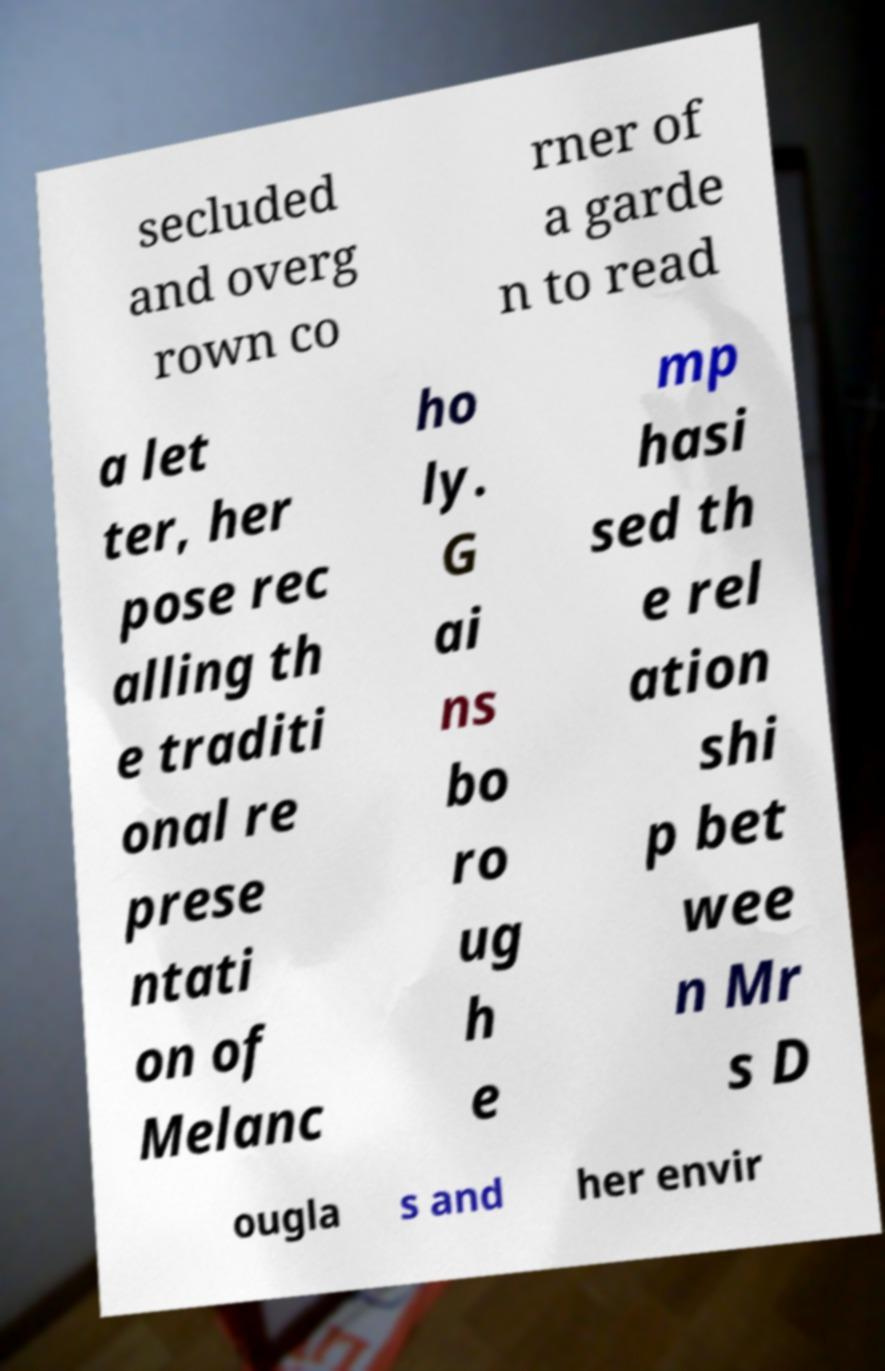There's text embedded in this image that I need extracted. Can you transcribe it verbatim? secluded and overg rown co rner of a garde n to read a let ter, her pose rec alling th e traditi onal re prese ntati on of Melanc ho ly. G ai ns bo ro ug h e mp hasi sed th e rel ation shi p bet wee n Mr s D ougla s and her envir 